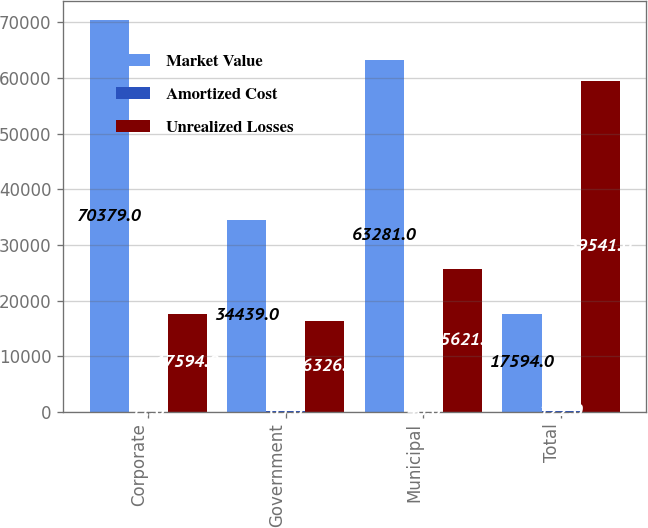Convert chart. <chart><loc_0><loc_0><loc_500><loc_500><stacked_bar_chart><ecel><fcel>Corporate<fcel>Government<fcel>Municipal<fcel>Total<nl><fcel>Market Value<fcel>70379<fcel>34439<fcel>63281<fcel>17594<nl><fcel>Amortized Cost<fcel>11<fcel>65<fcel>46<fcel>122<nl><fcel>Unrealized Losses<fcel>17594<fcel>16326<fcel>25621<fcel>59541<nl></chart> 